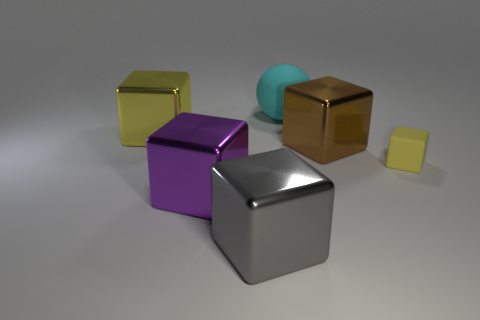How many cubes are in front of the big brown block and to the right of the large cyan matte thing?
Make the answer very short. 1. There is a yellow object right of the brown object; is its size the same as the big cyan matte object?
Provide a short and direct response. No. Are there any large spheres that have the same color as the large matte thing?
Your answer should be compact. No. There is a yellow cube that is made of the same material as the large purple object; what size is it?
Ensure brevity in your answer.  Large. Is the number of tiny yellow things to the right of the large rubber object greater than the number of large brown objects on the right side of the brown metallic thing?
Your answer should be very brief. Yes. How many other objects are the same material as the small yellow cube?
Offer a very short reply. 1. Do the yellow object that is left of the gray metallic object and the big cyan object have the same material?
Keep it short and to the point. No. What is the shape of the yellow matte thing?
Give a very brief answer. Cube. Is the number of yellow cubes that are in front of the brown metal thing greater than the number of tiny blue metal spheres?
Your answer should be compact. Yes. Is there any other thing that has the same shape as the cyan object?
Keep it short and to the point. No. 